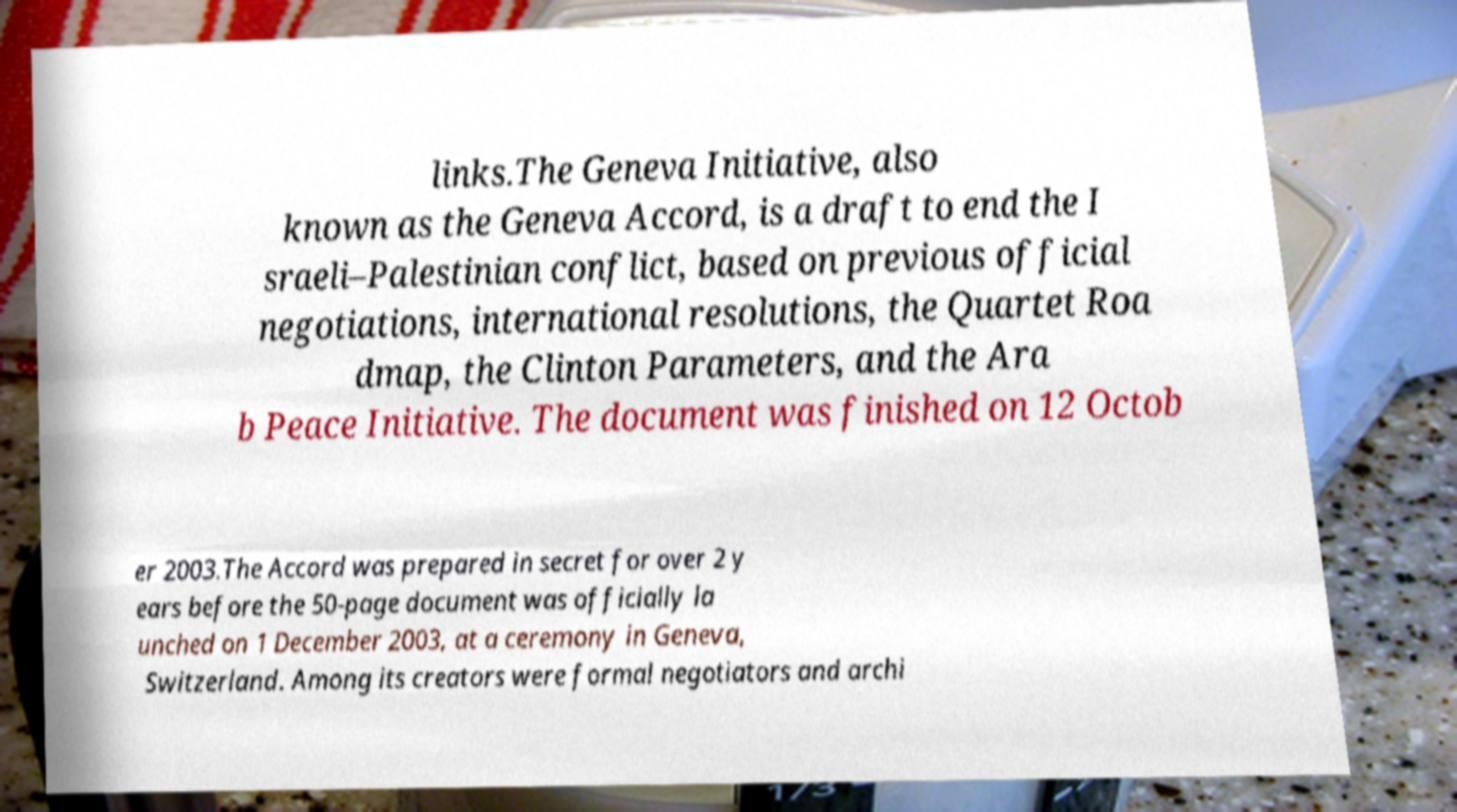Could you extract and type out the text from this image? links.The Geneva Initiative, also known as the Geneva Accord, is a draft to end the I sraeli–Palestinian conflict, based on previous official negotiations, international resolutions, the Quartet Roa dmap, the Clinton Parameters, and the Ara b Peace Initiative. The document was finished on 12 Octob er 2003.The Accord was prepared in secret for over 2 y ears before the 50-page document was officially la unched on 1 December 2003, at a ceremony in Geneva, Switzerland. Among its creators were formal negotiators and archi 